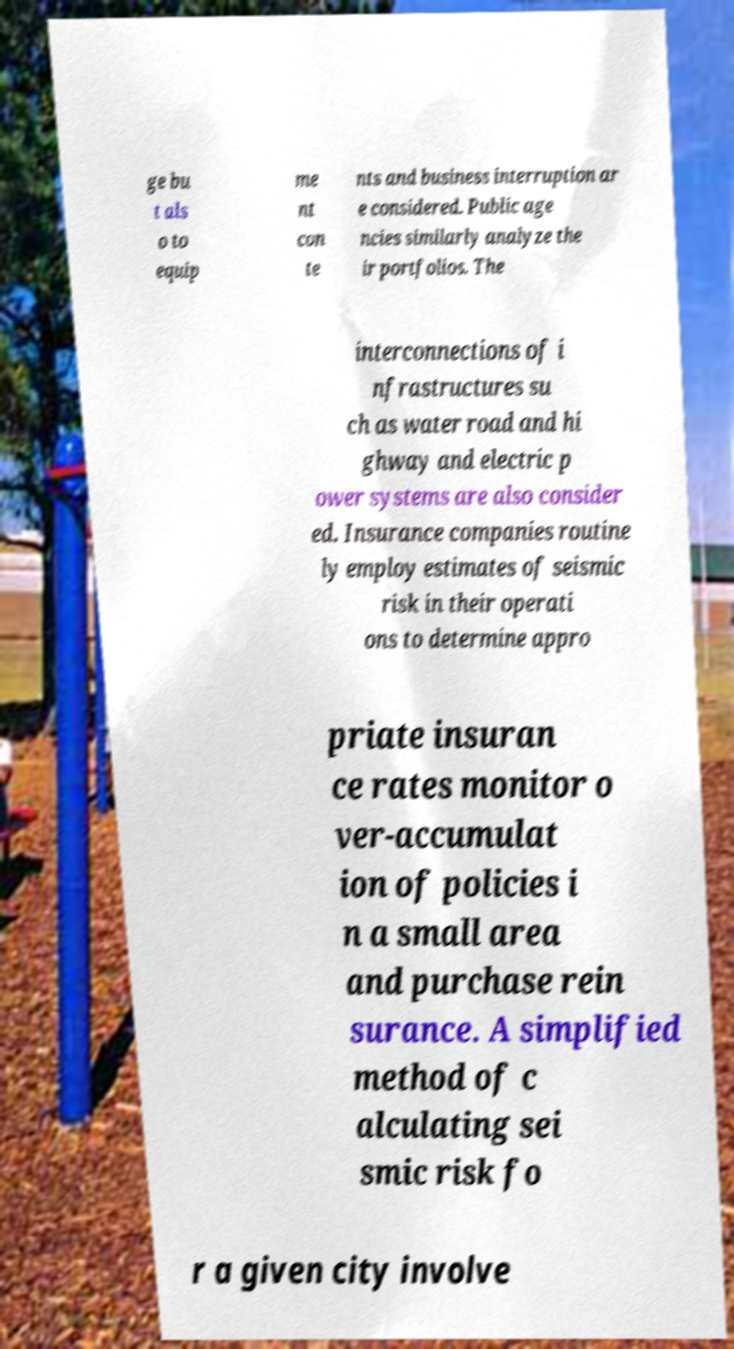Could you extract and type out the text from this image? ge bu t als o to equip me nt con te nts and business interruption ar e considered. Public age ncies similarly analyze the ir portfolios. The interconnections of i nfrastructures su ch as water road and hi ghway and electric p ower systems are also consider ed. Insurance companies routine ly employ estimates of seismic risk in their operati ons to determine appro priate insuran ce rates monitor o ver-accumulat ion of policies i n a small area and purchase rein surance. A simplified method of c alculating sei smic risk fo r a given city involve 